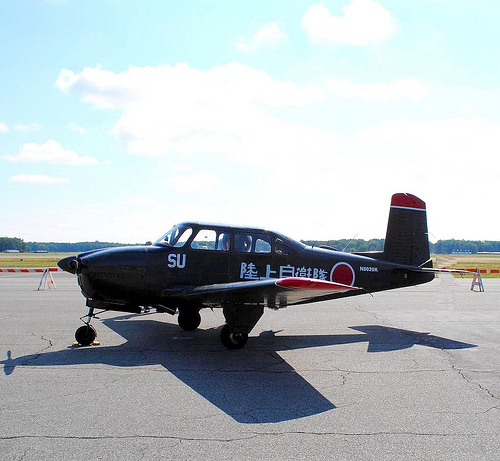Please provide a short description for this region: [0.77, 0.42, 0.86, 0.57]. This region shows the tail of the plane, distinguished by specific markings and design elements indicative of its model. 